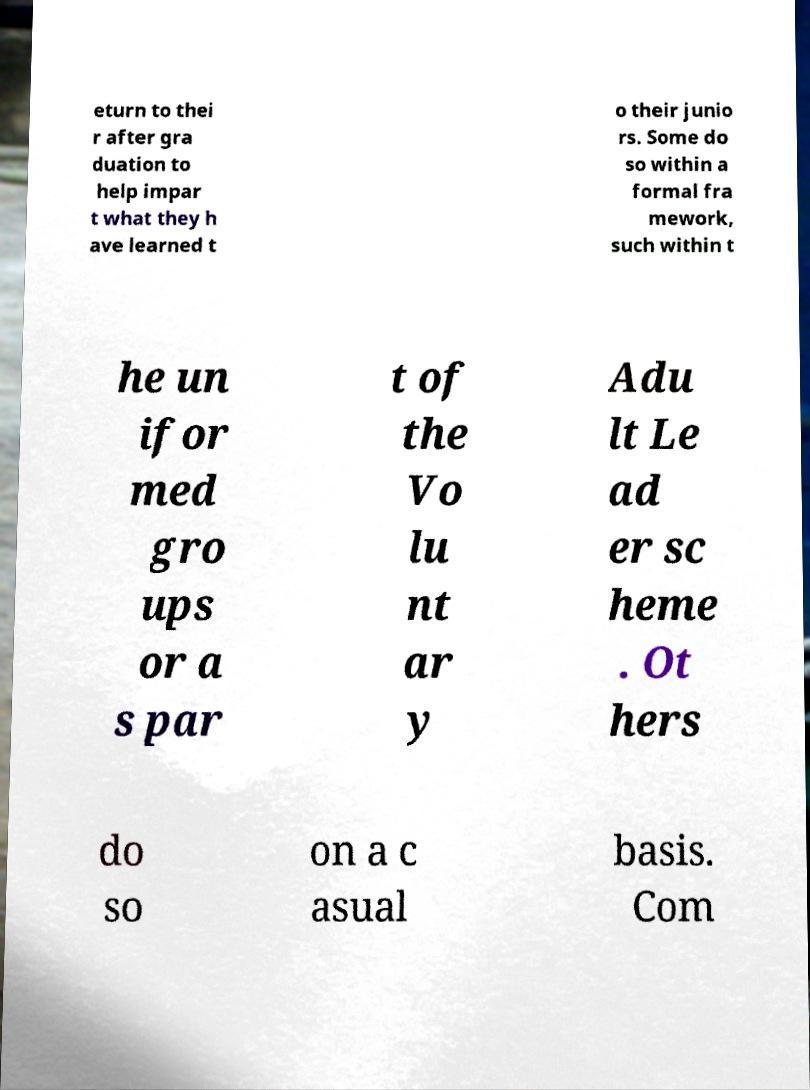Could you extract and type out the text from this image? eturn to thei r after gra duation to help impar t what they h ave learned t o their junio rs. Some do so within a formal fra mework, such within t he un ifor med gro ups or a s par t of the Vo lu nt ar y Adu lt Le ad er sc heme . Ot hers do so on a c asual basis. Com 